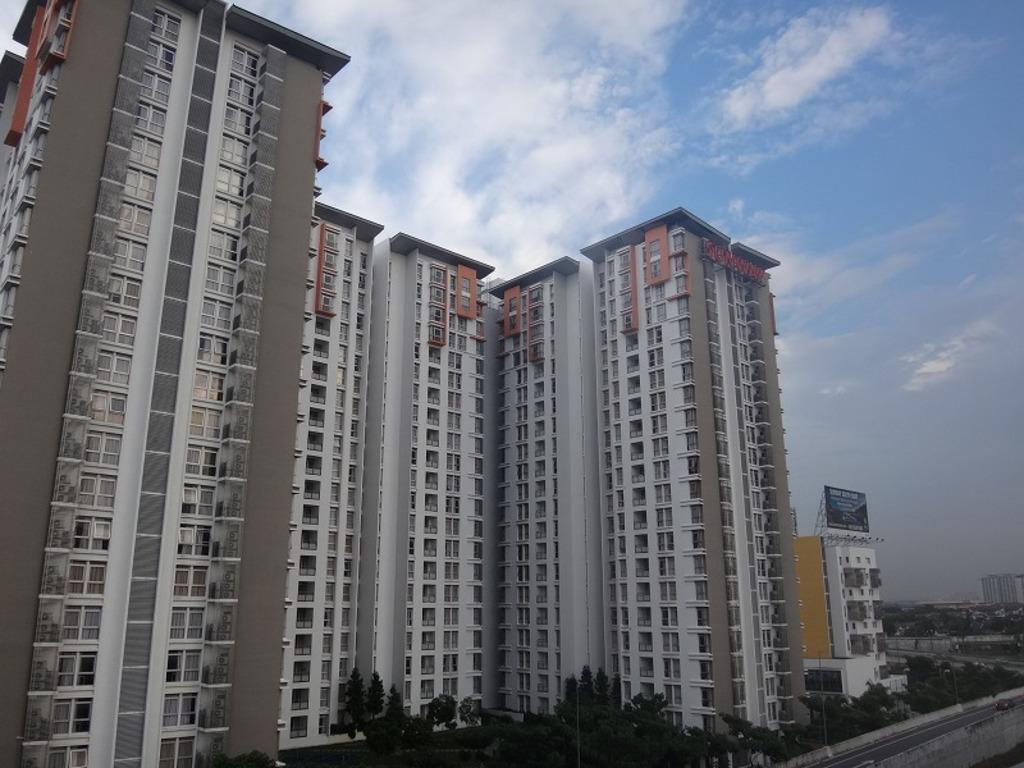What can be seen in the sky in the image? The sky with clouds is visible in the image. What type of buildings are present in the image? There are skyscrapers in the image. What else is present in the image besides buildings? Advertisements, grills, poles, roads, and trees are present in the image. What is the caption of the image? There is no caption present in the image. How much profit can be seen in the image? There is no mention of profit in the image; it focuses on the sky, skyscrapers, advertisements, grills, poles, roads, and trees. 